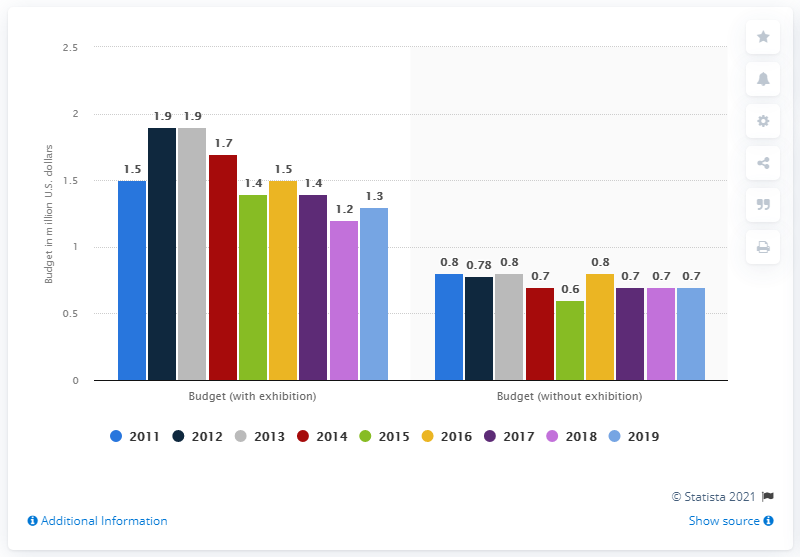Point out several critical features in this image. The highest green bar over the years has been 1.4. According to the information provided, the average budget for the largest event in 2019 was 1.3 million U.S. dollars. The difference between the highest budget value when exhibiting (with exhibition) and the lowest budget value when not exhibiting (without exhibition) over the years is 1.3. 